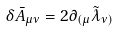Convert formula to latex. <formula><loc_0><loc_0><loc_500><loc_500>\delta \bar { A } _ { \mu \nu } = 2 \partial _ { ( \mu } \tilde { \lambda } _ { \nu ) }</formula> 